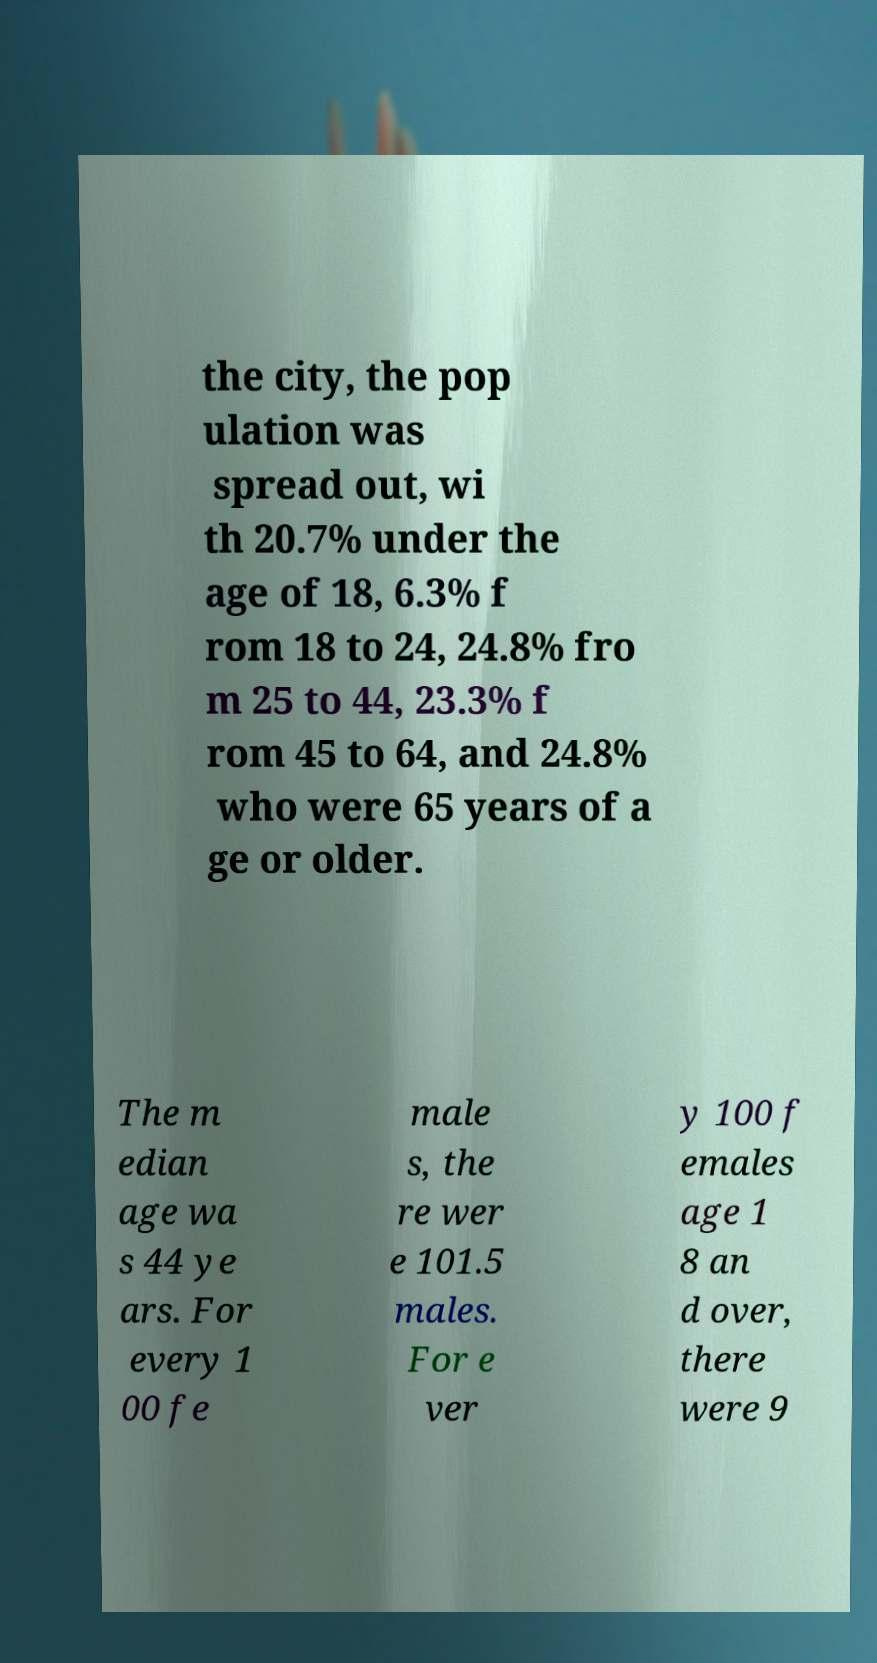I need the written content from this picture converted into text. Can you do that? the city, the pop ulation was spread out, wi th 20.7% under the age of 18, 6.3% f rom 18 to 24, 24.8% fro m 25 to 44, 23.3% f rom 45 to 64, and 24.8% who were 65 years of a ge or older. The m edian age wa s 44 ye ars. For every 1 00 fe male s, the re wer e 101.5 males. For e ver y 100 f emales age 1 8 an d over, there were 9 